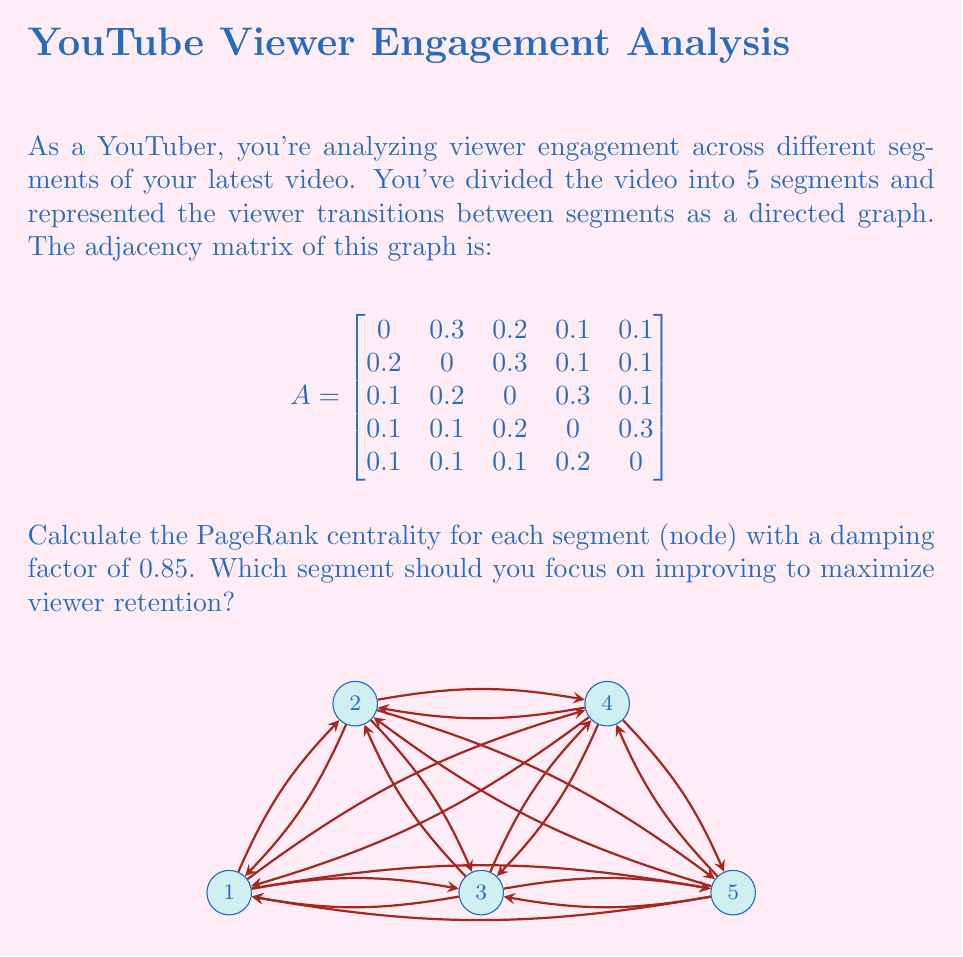Could you help me with this problem? To calculate the PageRank centrality, we'll use the power iteration method:

1) Initialize the PageRank vector $r$ with equal probabilities:
   $r_0 = [0.2, 0.2, 0.2, 0.2, 0.2]^T$

2) Apply the PageRank formula iteratively:
   $r_{k+1} = (1-d)e + d A^T r_k$
   where $d = 0.85$ is the damping factor, $e = [0.2, 0.2, 0.2, 0.2, 0.2]^T$, and $A^T$ is the transpose of the adjacency matrix.

3) Iterate until convergence (difference between consecutive iterations is small):

   Iteration 1:
   $r_1 = 0.15[0.2, 0.2, 0.2, 0.2, 0.2]^T + 0.85 A^T r_0$
   $r_1 = [0.205, 0.205, 0.215, 0.196, 0.179]^T$

   Iteration 2:
   $r_2 = [0.206, 0.207, 0.218, 0.195, 0.174]^T$

   Iteration 3:
   $r_3 = [0.206, 0.208, 0.220, 0.194, 0.172]^T$

   Iteration 4:
   $r_4 = [0.206, 0.208, 0.220, 0.194, 0.171]^T$

4) The process converges after 4 iterations. The final PageRank values are:
   Segment 1: 0.206
   Segment 2: 0.208
   Segment 3: 0.220
   Segment 4: 0.194
   Segment 5: 0.171

5) Segment 3 has the highest PageRank centrality, indicating it's the most central and influential segment in terms of viewer engagement.

Therefore, to maximize viewer retention, you should focus on improving Segment 3, as it has the highest impact on overall viewer engagement patterns.
Answer: Segment 3 